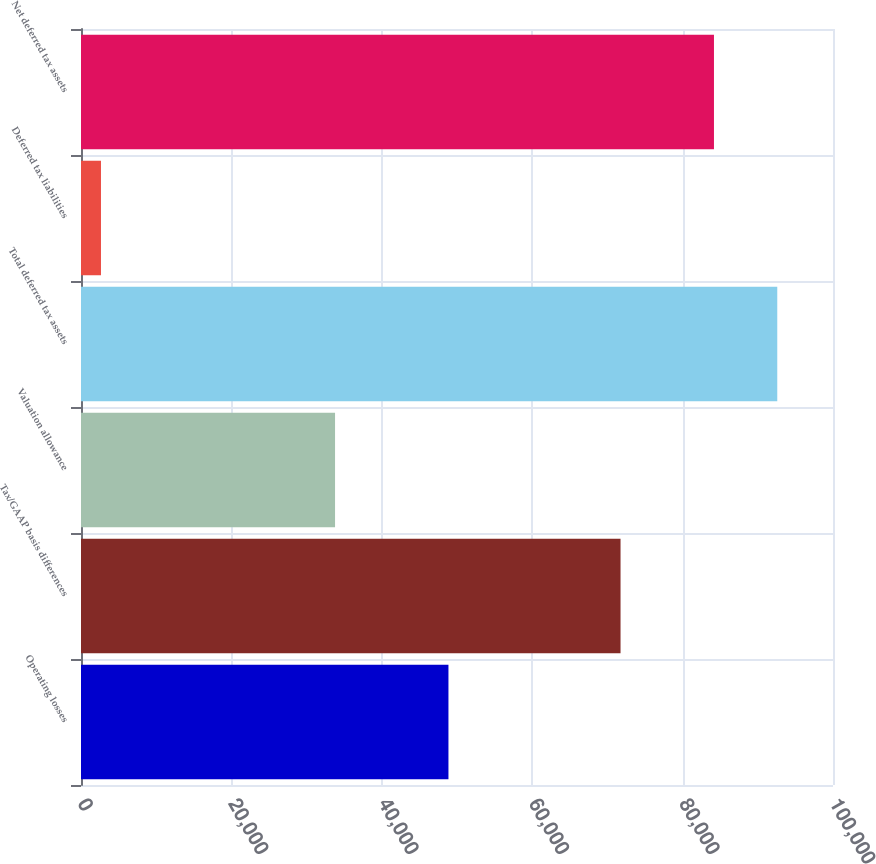Convert chart. <chart><loc_0><loc_0><loc_500><loc_500><bar_chart><fcel>Operating losses<fcel>Tax/GAAP basis differences<fcel>Valuation allowance<fcel>Total deferred tax assets<fcel>Deferred tax liabilities<fcel>Net deferred tax assets<nl><fcel>48863<fcel>71747<fcel>33783<fcel>92588.1<fcel>2656<fcel>84171<nl></chart> 